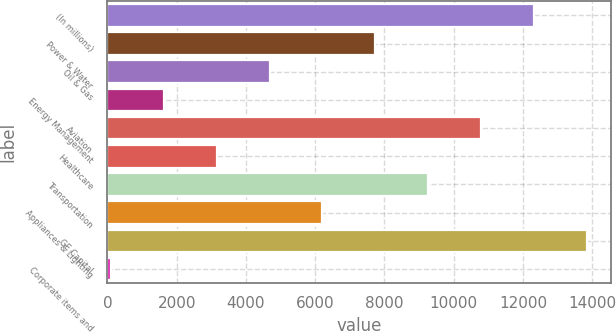Convert chart to OTSL. <chart><loc_0><loc_0><loc_500><loc_500><bar_chart><fcel>(In millions)<fcel>Power & Water<fcel>Oil & Gas<fcel>Energy Management<fcel>Aviation<fcel>Healthcare<fcel>Transportation<fcel>Appliances & Lighting<fcel>GE Capital<fcel>Corporate items and<nl><fcel>12319.8<fcel>7737<fcel>4681.8<fcel>1626.6<fcel>10792.2<fcel>3154.2<fcel>9264.6<fcel>6209.4<fcel>13847.4<fcel>99<nl></chart> 